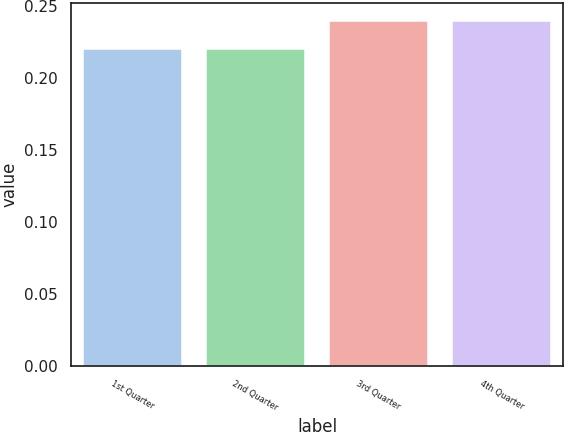Convert chart. <chart><loc_0><loc_0><loc_500><loc_500><bar_chart><fcel>1st Quarter<fcel>2nd Quarter<fcel>3rd Quarter<fcel>4th Quarter<nl><fcel>0.22<fcel>0.22<fcel>0.24<fcel>0.24<nl></chart> 